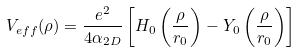<formula> <loc_0><loc_0><loc_500><loc_500>V _ { e f f } ( \rho ) = \frac { e ^ { 2 } } { 4 \alpha _ { 2 D } } \left [ H _ { 0 } \left ( \frac { \rho } { r _ { 0 } } \right ) - Y _ { 0 } \left ( \frac { \rho } { r _ { 0 } } \right ) \right ]</formula> 